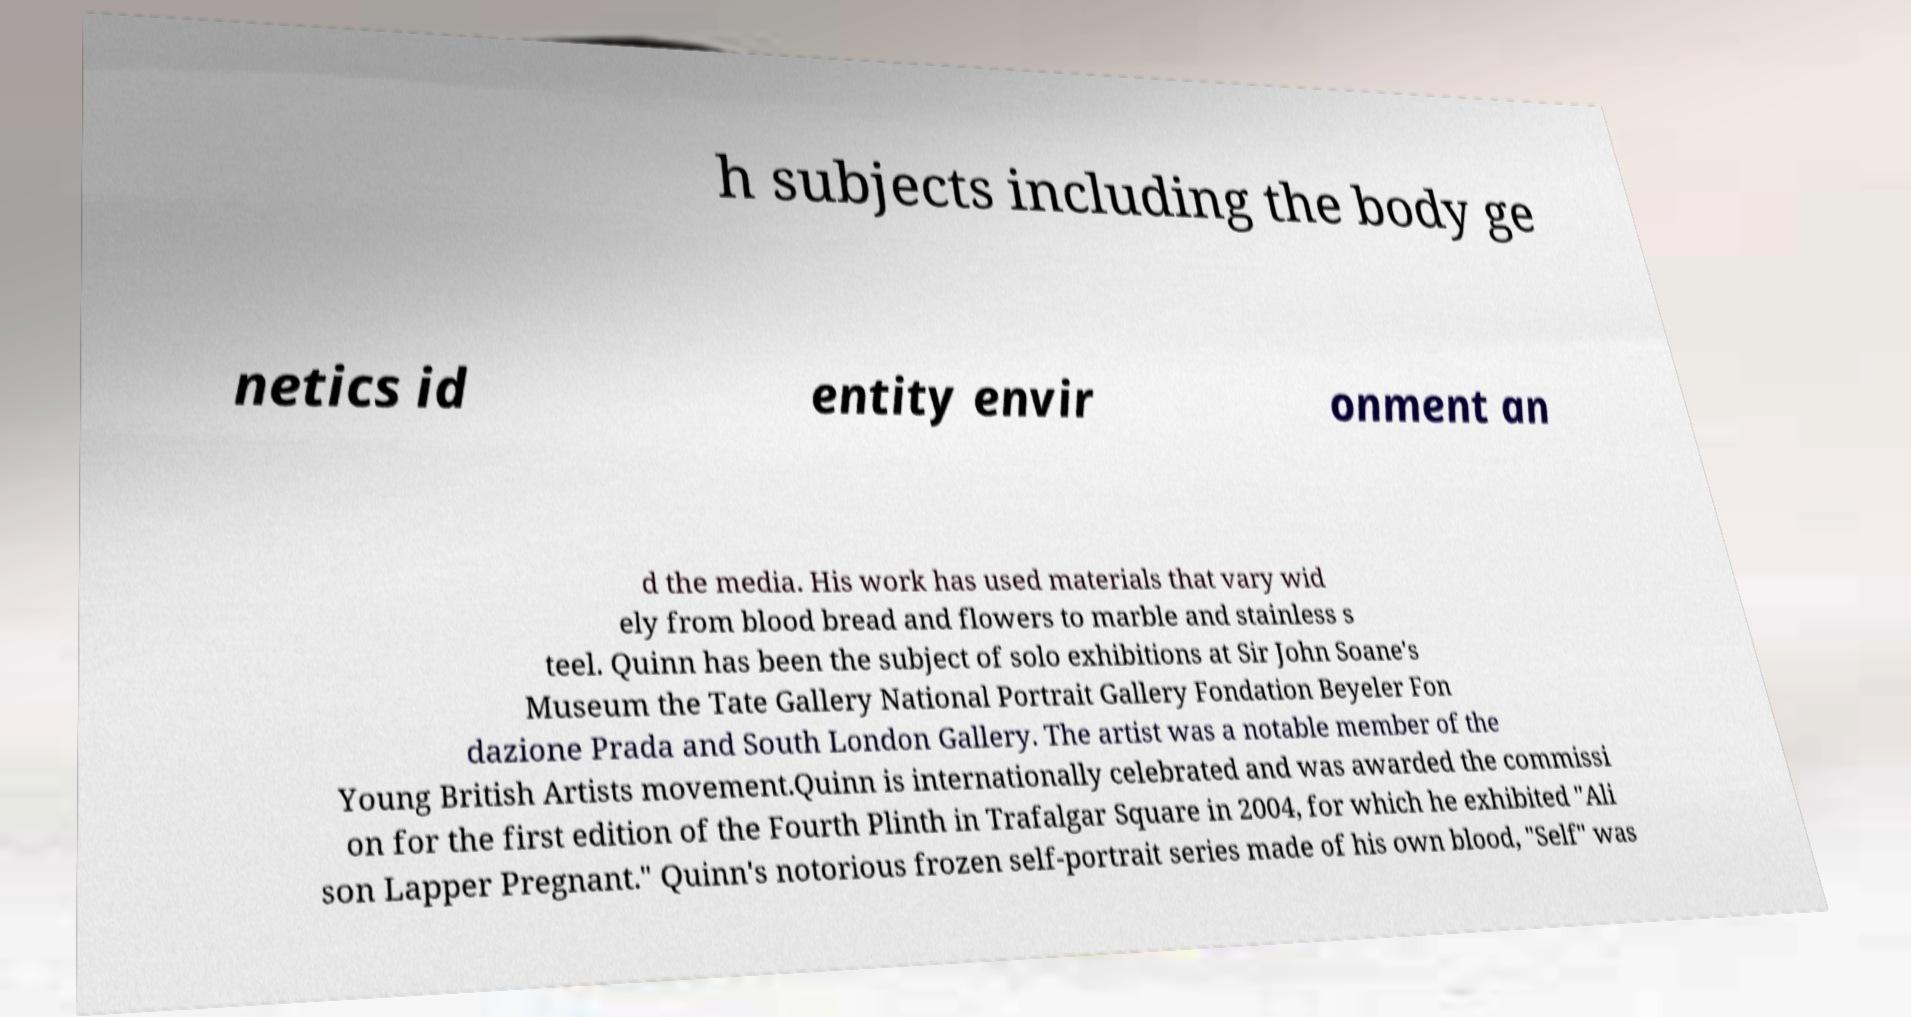I need the written content from this picture converted into text. Can you do that? h subjects including the body ge netics id entity envir onment an d the media. His work has used materials that vary wid ely from blood bread and flowers to marble and stainless s teel. Quinn has been the subject of solo exhibitions at Sir John Soane's Museum the Tate Gallery National Portrait Gallery Fondation Beyeler Fon dazione Prada and South London Gallery. The artist was a notable member of the Young British Artists movement.Quinn is internationally celebrated and was awarded the commissi on for the first edition of the Fourth Plinth in Trafalgar Square in 2004, for which he exhibited "Ali son Lapper Pregnant." Quinn's notorious frozen self-portrait series made of his own blood, "Self" was 